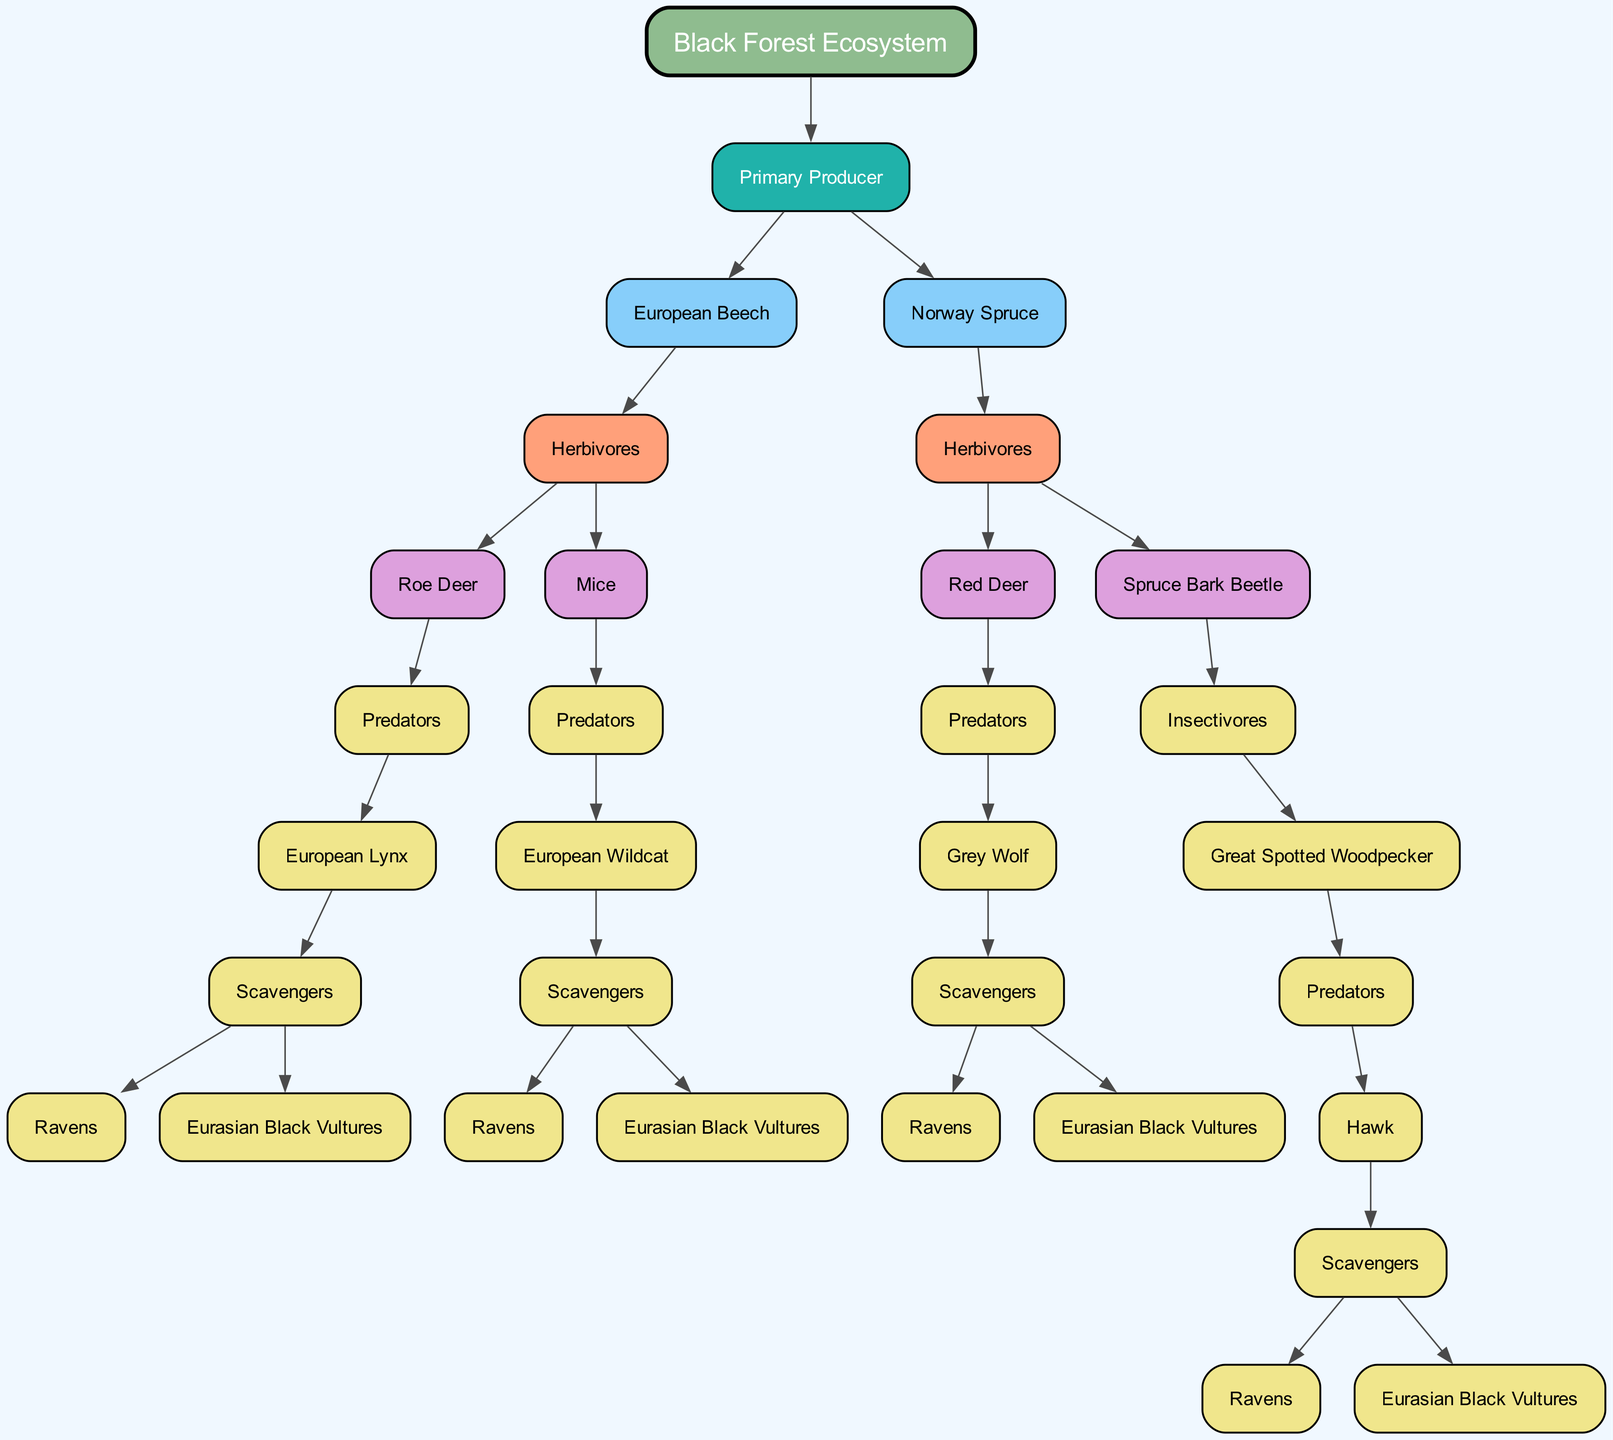What is the top-level node of the diagram? The diagram begins with the "Black Forest Ecosystem" as its root node, representing the entire structure and the foundation of the lineage of fauna interactions.
Answer: Black Forest Ecosystem How many primary producers are represented in the diagram? There are two primary producers listed: "European Beech" and "Norway Spruce." Counting them gives us a total of 2 primary producers.
Answer: 2 Which herbivore interacts with the European Lynx? The herbivore that directly interacts with the European Lynx is the "Roe Deer." This relationship is indicated by the lineage from the European Beech to the Roe Deer, then to its predator, which is the Lynx.
Answer: Roe Deer What type of predator is associated with the Red Deer? The Red Deer is associated with the "Grey Wolf" as its predator. This connection is established in the lineage stemming from the Norway Spruce to the Red Deer, followed by the predator node.
Answer: Grey Wolf How many scavengers are listed in the diagram? The diagram lists two scavengers: "Ravens" and "Eurasian Black Vultures." They appear in multiple locations related to various predators, totaling 2 distinct scavenger species.
Answer: 2 Which insectivore is linked to the Spruce Bark Beetle? The "Great Spotted Woodpecker" is identified as the insectivore linked to the Spruce Bark Beetle. This connection can be traced through the herbivore node of the Spruce Bark Beetle, which leads to the insectivore.
Answer: Great Spotted Woodpecker Who are the scavengers of the Grey Wolf? The scavengers associated with the Grey Wolf are "Ravens" and "Eurasian Black Vultures." This dual association is shown under the Grey Wolf's predator lineage, which leads to the scavenger node.
Answer: Ravens, Eurasian Black Vultures What is the relationship between Mice and the European Wildcat? Mice serve as a prey source for the European Wildcat, which is depicted by the lineage that flows from Mice to their predator, the Wildcat.
Answer: Prey Which herbivore has the most complex interaction chain in the diagram? The "Red Deer" has the most complex interaction chain, involving its relationship with the Grey Wolf as a predator and the subsequent scavengers associated with the predator. This chain reflects multiple layers of interaction.
Answer: Red Deer 